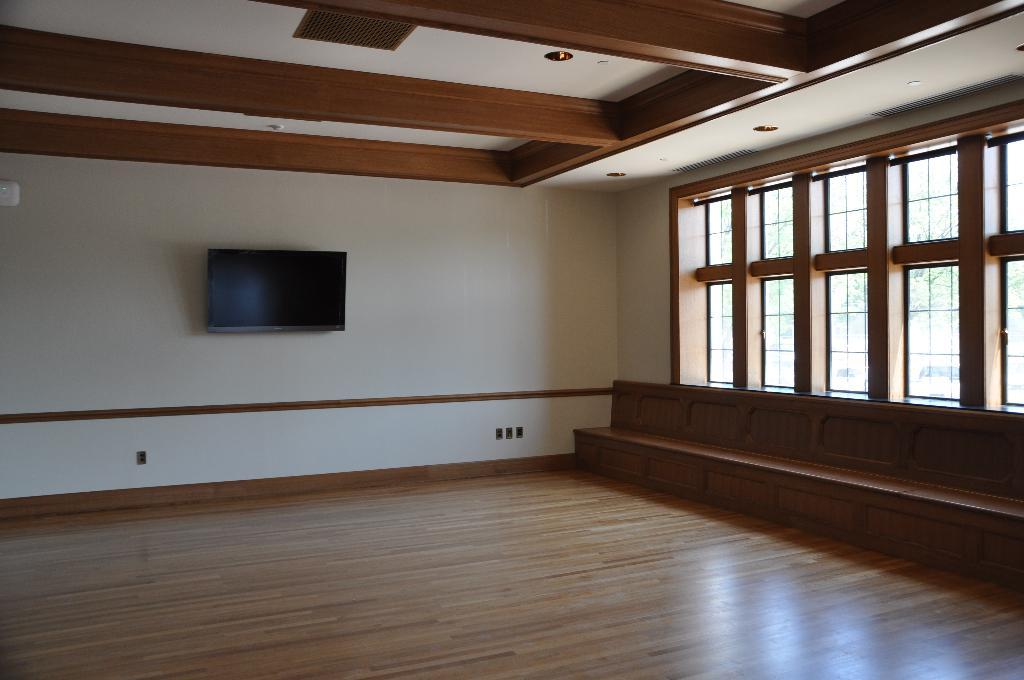What type of space is depicted in the image? The image shows the inside of a hall. What can be seen on the wall in the hall? There is a TV on the wall in the hall. Are there any sources of natural light in the hall? Yes, there are windows in the hall. What is the source of artificial light in the hall? There is a light on the ceiling in the hall. What type of flooring is present in the hall? The floor in the hall has a wooden mat. What type of doctor is standing near the TV in the image? There is no doctor present in the image; it shows the inside of a hall with a TV on the wall. What government policy is being discussed in the image? There is no discussion of government policy in the image; it shows the inside of a hall with a TV on the wall. 